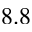Convert formula to latex. <formula><loc_0><loc_0><loc_500><loc_500>8 . 8</formula> 